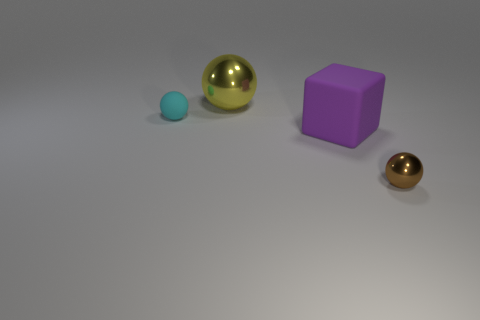Subtract all large spheres. How many spheres are left? 2 Add 3 tiny objects. How many objects exist? 7 Subtract all brown spheres. How many spheres are left? 2 Subtract all blocks. How many objects are left? 3 Subtract all gray spheres. Subtract all green blocks. How many spheres are left? 3 Subtract 1 brown balls. How many objects are left? 3 Subtract all large purple matte things. Subtract all big things. How many objects are left? 1 Add 1 big yellow balls. How many big yellow balls are left? 2 Add 3 tiny red things. How many tiny red things exist? 3 